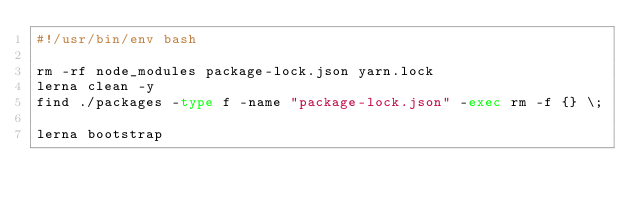Convert code to text. <code><loc_0><loc_0><loc_500><loc_500><_Bash_>#!/usr/bin/env bash

rm -rf node_modules package-lock.json yarn.lock
lerna clean -y
find ./packages -type f -name "package-lock.json" -exec rm -f {} \;

lerna bootstrap
</code> 